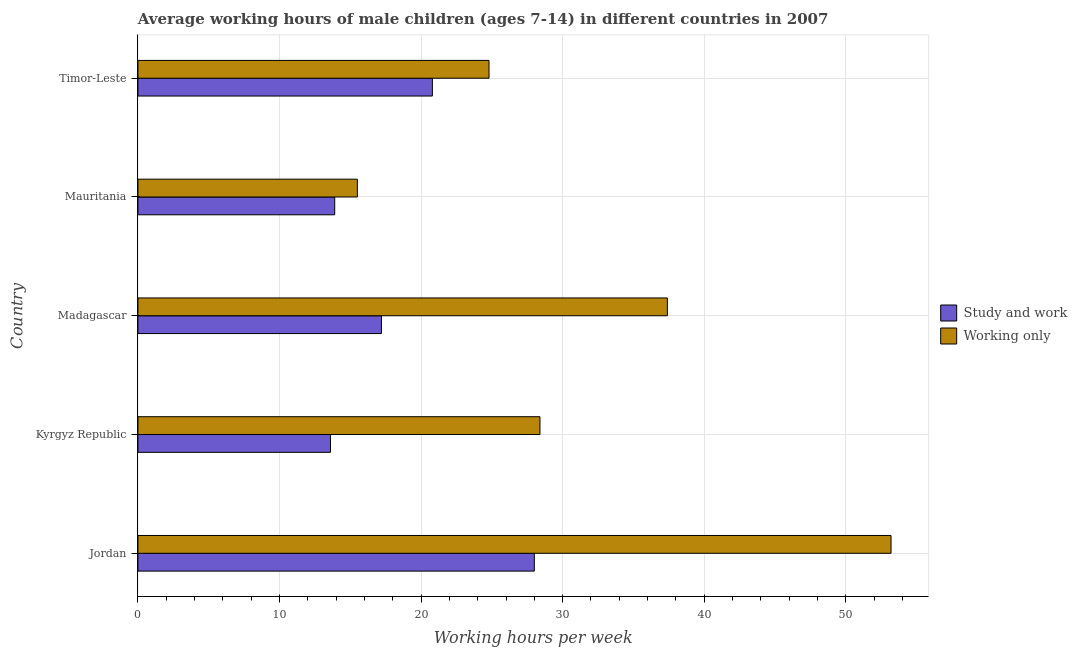How many groups of bars are there?
Ensure brevity in your answer.  5. Are the number of bars per tick equal to the number of legend labels?
Offer a terse response. Yes. What is the label of the 5th group of bars from the top?
Keep it short and to the point. Jordan. In how many cases, is the number of bars for a given country not equal to the number of legend labels?
Keep it short and to the point. 0. What is the average working hour of children involved in only work in Kyrgyz Republic?
Make the answer very short. 28.4. Across all countries, what is the maximum average working hour of children involved in study and work?
Make the answer very short. 28. Across all countries, what is the minimum average working hour of children involved in study and work?
Your answer should be very brief. 13.6. In which country was the average working hour of children involved in only work maximum?
Offer a terse response. Jordan. In which country was the average working hour of children involved in only work minimum?
Your response must be concise. Mauritania. What is the total average working hour of children involved in only work in the graph?
Provide a short and direct response. 159.3. What is the difference between the average working hour of children involved in study and work in Madagascar and that in Mauritania?
Offer a terse response. 3.3. What is the difference between the average working hour of children involved in study and work in Kyrgyz Republic and the average working hour of children involved in only work in Madagascar?
Your response must be concise. -23.8. What is the difference between the average working hour of children involved in study and work and average working hour of children involved in only work in Kyrgyz Republic?
Provide a succinct answer. -14.8. What is the ratio of the average working hour of children involved in only work in Madagascar to that in Timor-Leste?
Offer a terse response. 1.51. Is the average working hour of children involved in only work in Madagascar less than that in Mauritania?
Make the answer very short. No. Is the difference between the average working hour of children involved in only work in Kyrgyz Republic and Timor-Leste greater than the difference between the average working hour of children involved in study and work in Kyrgyz Republic and Timor-Leste?
Give a very brief answer. Yes. What is the difference between the highest and the lowest average working hour of children involved in only work?
Provide a succinct answer. 37.7. What does the 1st bar from the top in Madagascar represents?
Make the answer very short. Working only. What does the 2nd bar from the bottom in Madagascar represents?
Offer a very short reply. Working only. How many bars are there?
Your response must be concise. 10. How many countries are there in the graph?
Provide a succinct answer. 5. What is the difference between two consecutive major ticks on the X-axis?
Give a very brief answer. 10. Does the graph contain grids?
Make the answer very short. Yes. How are the legend labels stacked?
Offer a terse response. Vertical. What is the title of the graph?
Make the answer very short. Average working hours of male children (ages 7-14) in different countries in 2007. Does "Lowest 10% of population" appear as one of the legend labels in the graph?
Provide a succinct answer. No. What is the label or title of the X-axis?
Provide a succinct answer. Working hours per week. What is the Working hours per week of Study and work in Jordan?
Your answer should be compact. 28. What is the Working hours per week in Working only in Jordan?
Offer a terse response. 53.2. What is the Working hours per week in Study and work in Kyrgyz Republic?
Your response must be concise. 13.6. What is the Working hours per week in Working only in Kyrgyz Republic?
Provide a short and direct response. 28.4. What is the Working hours per week of Working only in Madagascar?
Provide a succinct answer. 37.4. What is the Working hours per week of Study and work in Mauritania?
Offer a terse response. 13.9. What is the Working hours per week of Working only in Mauritania?
Give a very brief answer. 15.5. What is the Working hours per week in Study and work in Timor-Leste?
Provide a short and direct response. 20.8. What is the Working hours per week in Working only in Timor-Leste?
Provide a short and direct response. 24.8. Across all countries, what is the maximum Working hours per week in Study and work?
Keep it short and to the point. 28. Across all countries, what is the maximum Working hours per week in Working only?
Give a very brief answer. 53.2. Across all countries, what is the minimum Working hours per week in Study and work?
Your answer should be compact. 13.6. Across all countries, what is the minimum Working hours per week in Working only?
Ensure brevity in your answer.  15.5. What is the total Working hours per week in Study and work in the graph?
Offer a very short reply. 93.5. What is the total Working hours per week in Working only in the graph?
Give a very brief answer. 159.3. What is the difference between the Working hours per week in Working only in Jordan and that in Kyrgyz Republic?
Offer a very short reply. 24.8. What is the difference between the Working hours per week of Working only in Jordan and that in Madagascar?
Your answer should be very brief. 15.8. What is the difference between the Working hours per week in Working only in Jordan and that in Mauritania?
Your answer should be very brief. 37.7. What is the difference between the Working hours per week of Study and work in Jordan and that in Timor-Leste?
Your answer should be compact. 7.2. What is the difference between the Working hours per week of Working only in Jordan and that in Timor-Leste?
Provide a short and direct response. 28.4. What is the difference between the Working hours per week in Working only in Kyrgyz Republic and that in Madagascar?
Provide a short and direct response. -9. What is the difference between the Working hours per week in Working only in Kyrgyz Republic and that in Mauritania?
Your response must be concise. 12.9. What is the difference between the Working hours per week of Study and work in Kyrgyz Republic and that in Timor-Leste?
Ensure brevity in your answer.  -7.2. What is the difference between the Working hours per week of Working only in Kyrgyz Republic and that in Timor-Leste?
Provide a short and direct response. 3.6. What is the difference between the Working hours per week of Working only in Madagascar and that in Mauritania?
Offer a very short reply. 21.9. What is the difference between the Working hours per week of Study and work in Madagascar and that in Timor-Leste?
Keep it short and to the point. -3.6. What is the difference between the Working hours per week of Study and work in Mauritania and that in Timor-Leste?
Your answer should be very brief. -6.9. What is the difference between the Working hours per week in Working only in Mauritania and that in Timor-Leste?
Your response must be concise. -9.3. What is the difference between the Working hours per week in Study and work in Jordan and the Working hours per week in Working only in Madagascar?
Provide a short and direct response. -9.4. What is the difference between the Working hours per week in Study and work in Kyrgyz Republic and the Working hours per week in Working only in Madagascar?
Provide a succinct answer. -23.8. What is the average Working hours per week in Study and work per country?
Your answer should be very brief. 18.7. What is the average Working hours per week of Working only per country?
Keep it short and to the point. 31.86. What is the difference between the Working hours per week in Study and work and Working hours per week in Working only in Jordan?
Keep it short and to the point. -25.2. What is the difference between the Working hours per week in Study and work and Working hours per week in Working only in Kyrgyz Republic?
Your answer should be very brief. -14.8. What is the difference between the Working hours per week in Study and work and Working hours per week in Working only in Madagascar?
Offer a very short reply. -20.2. What is the difference between the Working hours per week in Study and work and Working hours per week in Working only in Timor-Leste?
Your answer should be compact. -4. What is the ratio of the Working hours per week of Study and work in Jordan to that in Kyrgyz Republic?
Provide a short and direct response. 2.06. What is the ratio of the Working hours per week of Working only in Jordan to that in Kyrgyz Republic?
Provide a short and direct response. 1.87. What is the ratio of the Working hours per week of Study and work in Jordan to that in Madagascar?
Ensure brevity in your answer.  1.63. What is the ratio of the Working hours per week of Working only in Jordan to that in Madagascar?
Offer a very short reply. 1.42. What is the ratio of the Working hours per week in Study and work in Jordan to that in Mauritania?
Your answer should be compact. 2.01. What is the ratio of the Working hours per week in Working only in Jordan to that in Mauritania?
Provide a short and direct response. 3.43. What is the ratio of the Working hours per week of Study and work in Jordan to that in Timor-Leste?
Make the answer very short. 1.35. What is the ratio of the Working hours per week of Working only in Jordan to that in Timor-Leste?
Provide a succinct answer. 2.15. What is the ratio of the Working hours per week of Study and work in Kyrgyz Republic to that in Madagascar?
Keep it short and to the point. 0.79. What is the ratio of the Working hours per week of Working only in Kyrgyz Republic to that in Madagascar?
Offer a terse response. 0.76. What is the ratio of the Working hours per week of Study and work in Kyrgyz Republic to that in Mauritania?
Give a very brief answer. 0.98. What is the ratio of the Working hours per week in Working only in Kyrgyz Republic to that in Mauritania?
Your answer should be very brief. 1.83. What is the ratio of the Working hours per week of Study and work in Kyrgyz Republic to that in Timor-Leste?
Offer a very short reply. 0.65. What is the ratio of the Working hours per week in Working only in Kyrgyz Republic to that in Timor-Leste?
Ensure brevity in your answer.  1.15. What is the ratio of the Working hours per week in Study and work in Madagascar to that in Mauritania?
Give a very brief answer. 1.24. What is the ratio of the Working hours per week of Working only in Madagascar to that in Mauritania?
Provide a succinct answer. 2.41. What is the ratio of the Working hours per week of Study and work in Madagascar to that in Timor-Leste?
Your response must be concise. 0.83. What is the ratio of the Working hours per week of Working only in Madagascar to that in Timor-Leste?
Keep it short and to the point. 1.51. What is the ratio of the Working hours per week of Study and work in Mauritania to that in Timor-Leste?
Keep it short and to the point. 0.67. What is the ratio of the Working hours per week in Working only in Mauritania to that in Timor-Leste?
Make the answer very short. 0.62. What is the difference between the highest and the second highest Working hours per week of Working only?
Offer a terse response. 15.8. What is the difference between the highest and the lowest Working hours per week in Study and work?
Offer a very short reply. 14.4. What is the difference between the highest and the lowest Working hours per week of Working only?
Your answer should be very brief. 37.7. 